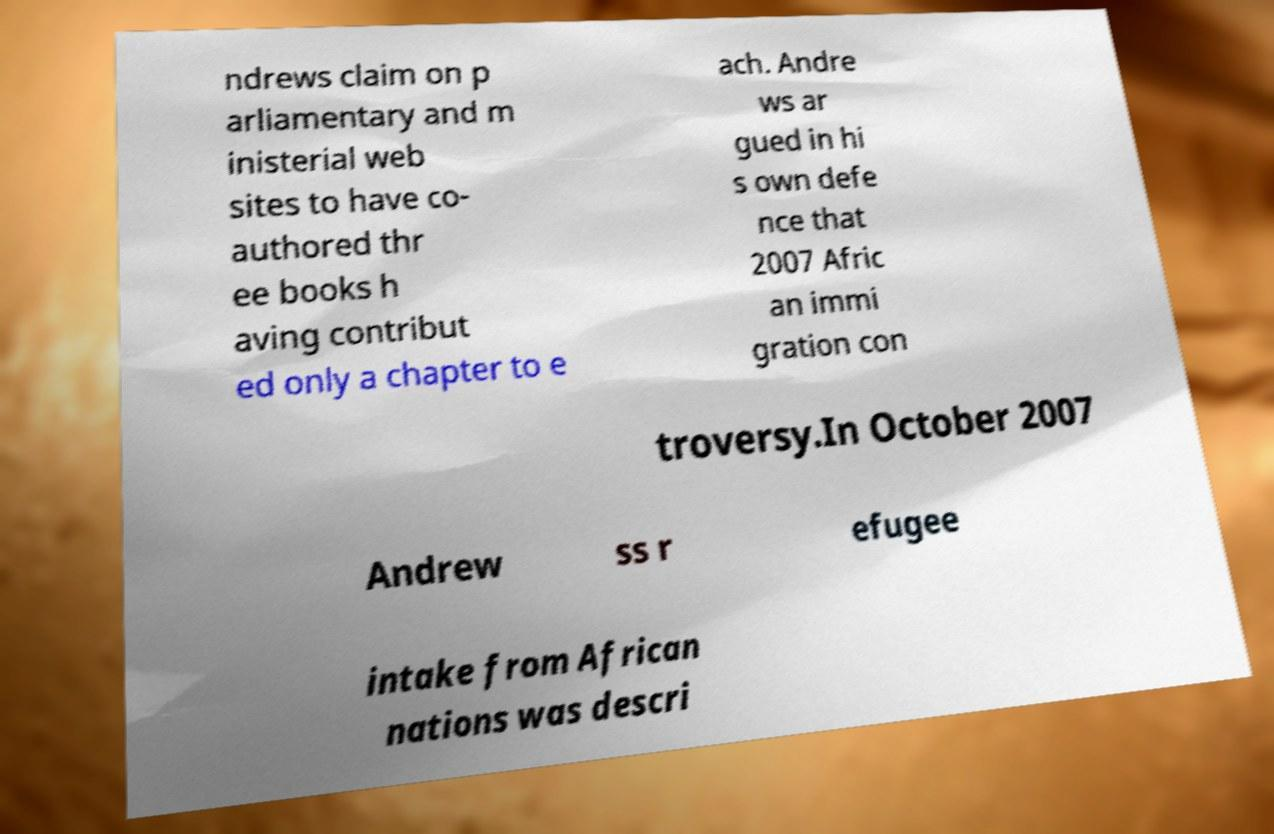For documentation purposes, I need the text within this image transcribed. Could you provide that? ndrews claim on p arliamentary and m inisterial web sites to have co- authored thr ee books h aving contribut ed only a chapter to e ach. Andre ws ar gued in hi s own defe nce that 2007 Afric an immi gration con troversy.In October 2007 Andrew ss r efugee intake from African nations was descri 